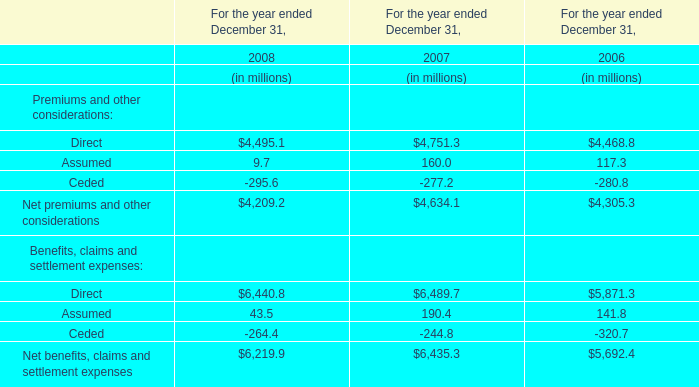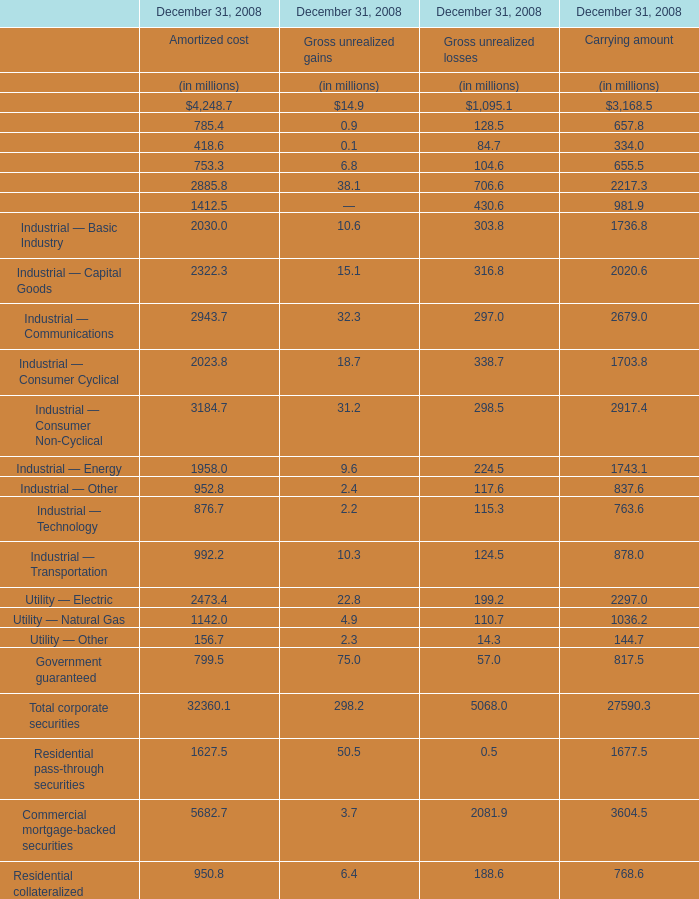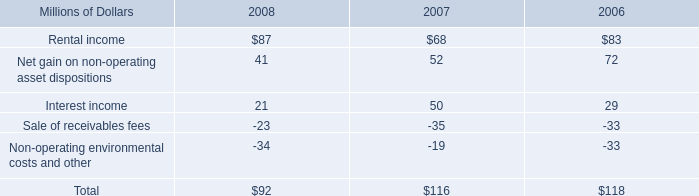what was the percentage change in rental income from 2007 to 2008? 
Computations: ((87 - 68) / 68)
Answer: 0.27941. 